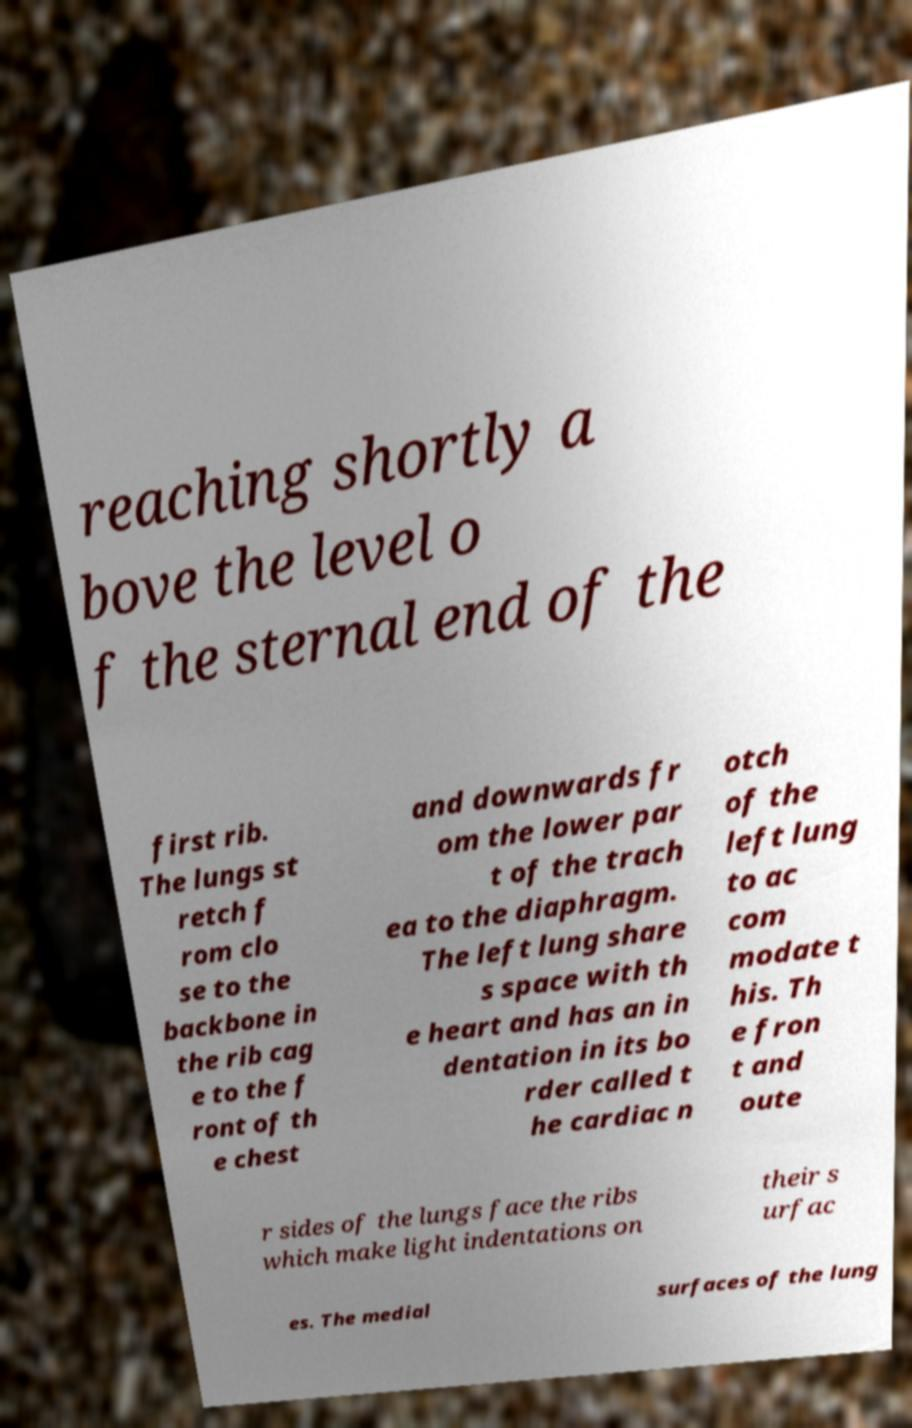Can you accurately transcribe the text from the provided image for me? reaching shortly a bove the level o f the sternal end of the first rib. The lungs st retch f rom clo se to the backbone in the rib cag e to the f ront of th e chest and downwards fr om the lower par t of the trach ea to the diaphragm. The left lung share s space with th e heart and has an in dentation in its bo rder called t he cardiac n otch of the left lung to ac com modate t his. Th e fron t and oute r sides of the lungs face the ribs which make light indentations on their s urfac es. The medial surfaces of the lung 